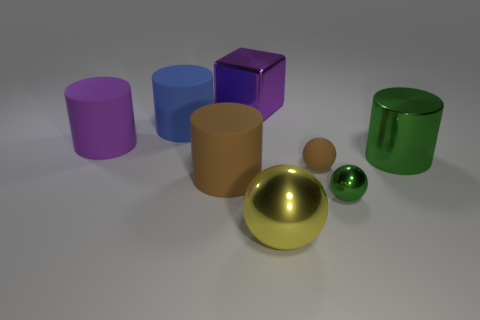Add 2 red matte spheres. How many objects exist? 10 Subtract all blocks. How many objects are left? 7 Subtract all small spheres. Subtract all big shiny cubes. How many objects are left? 5 Add 7 tiny rubber spheres. How many tiny rubber spheres are left? 8 Add 8 purple metallic blocks. How many purple metallic blocks exist? 9 Subtract 0 gray spheres. How many objects are left? 8 